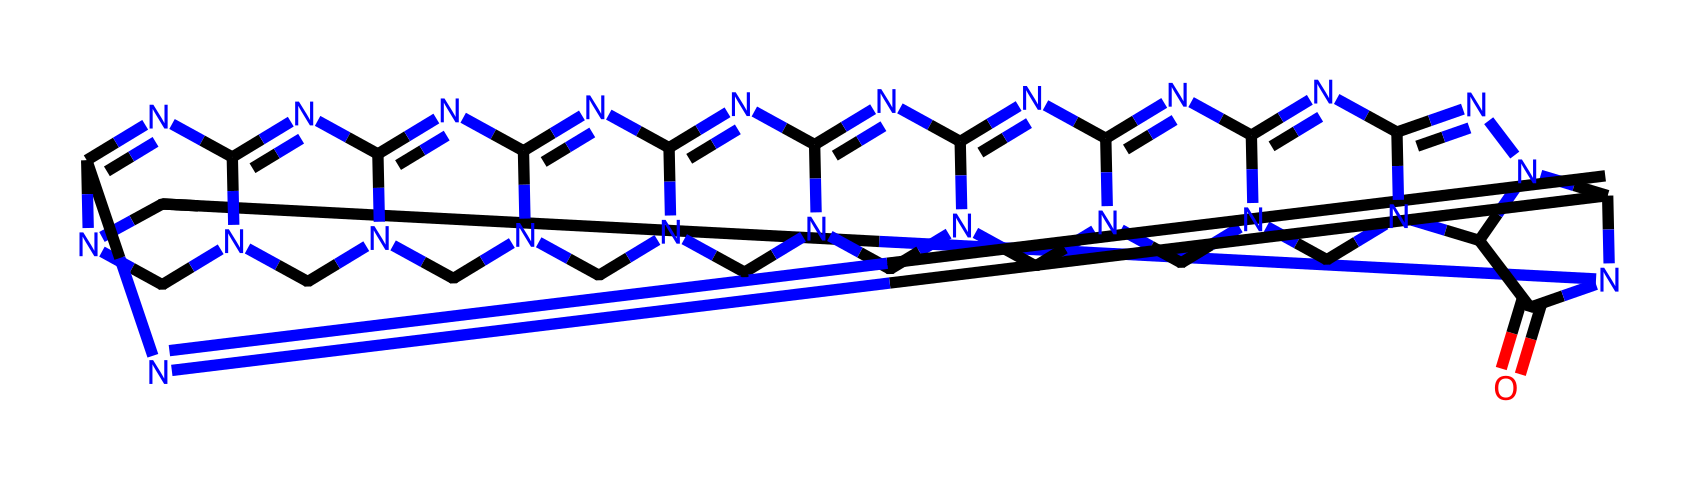What is the molecular formula of cucurbituril? By analyzing the SMILES representation, we can count the number of each type of atom present. In this case, we notice there are 12 carbon atoms (C), 12 nitrogen atoms (N), and 1 oxygen atom (O). Consequently, the molecular formula is C12N12O.
Answer: C12N12O How many nitrogen atoms are in the structure? In the provided SMILES representation, we count the occurrences of the nitrogen atom (N). There are a total of 12 instances of nitrogen, indicating that the molecule contains 12 nitrogen atoms.
Answer: 12 What shape does cucurbituril resemble? The name 'cucurbituril' derives from the Latin 'cucurbita,' meaning pumpkin, which indicates the molecule has a pumpkin-like or cage structure. Additionally, its SMILES suggests it has a larger cavity surrounded by various nitrogen atoms in a coordinated framework, reminiscent of a pumpkin shape.
Answer: pumpkin What is a potential application of cucurbituril? Cucurbituril's structure and properties allow for potential applications in drug delivery systems and environmental remediation, allowing it to encapsulate various guest molecules for targeted delivery or to bind environmental pollutants for removal.
Answer: drug delivery What type of compound is cucurbituril classified as? Cucurbituril is classified as a cage compound due to its unique structure that can encapsulate guest molecules within its cavity. Cage compounds are defined by their ability to trap or contain other molecules, which is central to their functionality.
Answer: cage compound How many carbon atoms are present in the chemical structure? By inspecting the SMILES notation, we can count the number of carbon atoms represented by 'C' in the chemical structure. There are a total of 12 carbon atoms present.
Answer: 12 What is the significance of nitrogen in cucurbituril? The presence of nitrogen atoms contributes to the overall stability and chemical interactions of cucurbituril. These nitrogen atoms play a crucial role in forming hydrogen bonds with guest molecules, enhancing the compound's ability to operate in various applications like drug delivery.
Answer: stability and interactions 